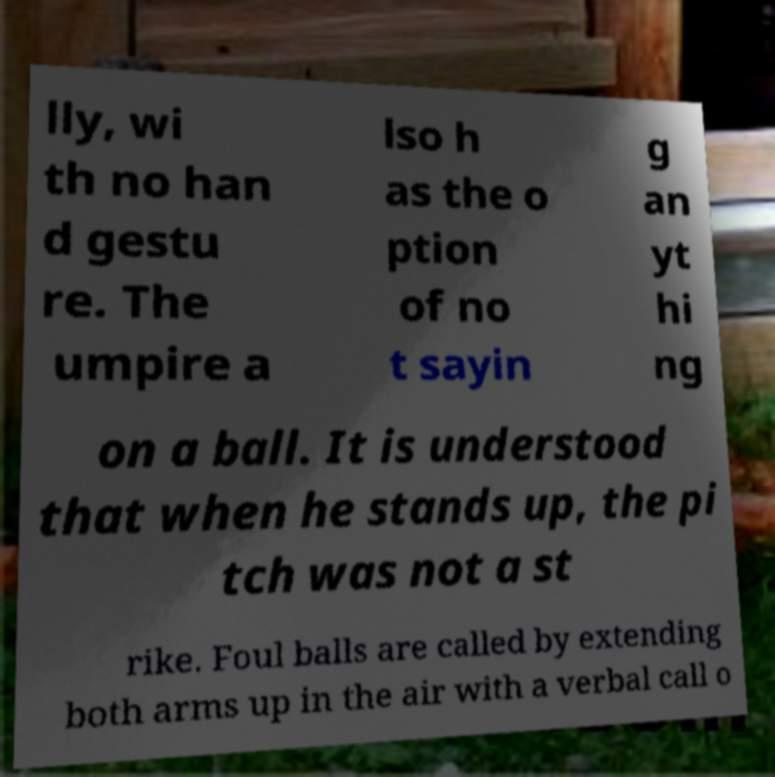Please identify and transcribe the text found in this image. lly, wi th no han d gestu re. The umpire a lso h as the o ption of no t sayin g an yt hi ng on a ball. It is understood that when he stands up, the pi tch was not a st rike. Foul balls are called by extending both arms up in the air with a verbal call o 